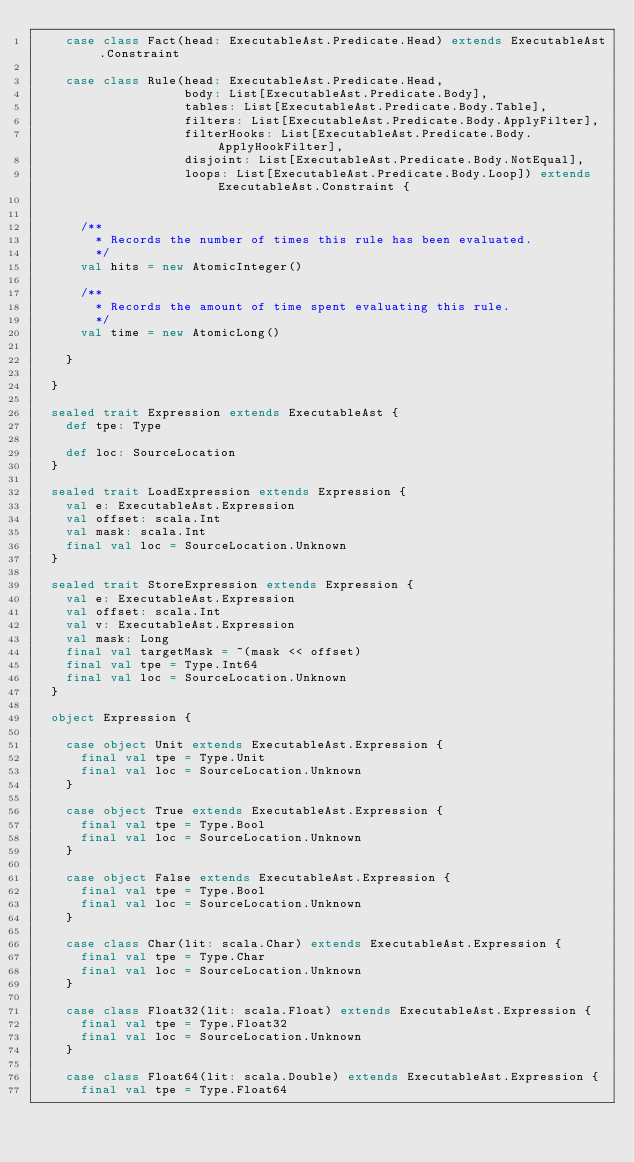<code> <loc_0><loc_0><loc_500><loc_500><_Scala_>    case class Fact(head: ExecutableAst.Predicate.Head) extends ExecutableAst.Constraint

    case class Rule(head: ExecutableAst.Predicate.Head,
                    body: List[ExecutableAst.Predicate.Body],
                    tables: List[ExecutableAst.Predicate.Body.Table],
                    filters: List[ExecutableAst.Predicate.Body.ApplyFilter],
                    filterHooks: List[ExecutableAst.Predicate.Body.ApplyHookFilter],
                    disjoint: List[ExecutableAst.Predicate.Body.NotEqual],
                    loops: List[ExecutableAst.Predicate.Body.Loop]) extends ExecutableAst.Constraint {


      /**
        * Records the number of times this rule has been evaluated.
        */
      val hits = new AtomicInteger()

      /**
        * Records the amount of time spent evaluating this rule.
        */
      val time = new AtomicLong()

    }

  }

  sealed trait Expression extends ExecutableAst {
    def tpe: Type

    def loc: SourceLocation
  }

  sealed trait LoadExpression extends Expression {
    val e: ExecutableAst.Expression
    val offset: scala.Int
    val mask: scala.Int
    final val loc = SourceLocation.Unknown
  }

  sealed trait StoreExpression extends Expression {
    val e: ExecutableAst.Expression
    val offset: scala.Int
    val v: ExecutableAst.Expression
    val mask: Long
    final val targetMask = ~(mask << offset)
    final val tpe = Type.Int64
    final val loc = SourceLocation.Unknown
  }

  object Expression {

    case object Unit extends ExecutableAst.Expression {
      final val tpe = Type.Unit
      final val loc = SourceLocation.Unknown
    }

    case object True extends ExecutableAst.Expression {
      final val tpe = Type.Bool
      final val loc = SourceLocation.Unknown
    }

    case object False extends ExecutableAst.Expression {
      final val tpe = Type.Bool
      final val loc = SourceLocation.Unknown
    }

    case class Char(lit: scala.Char) extends ExecutableAst.Expression {
      final val tpe = Type.Char
      final val loc = SourceLocation.Unknown
    }

    case class Float32(lit: scala.Float) extends ExecutableAst.Expression {
      final val tpe = Type.Float32
      final val loc = SourceLocation.Unknown
    }

    case class Float64(lit: scala.Double) extends ExecutableAst.Expression {
      final val tpe = Type.Float64</code> 